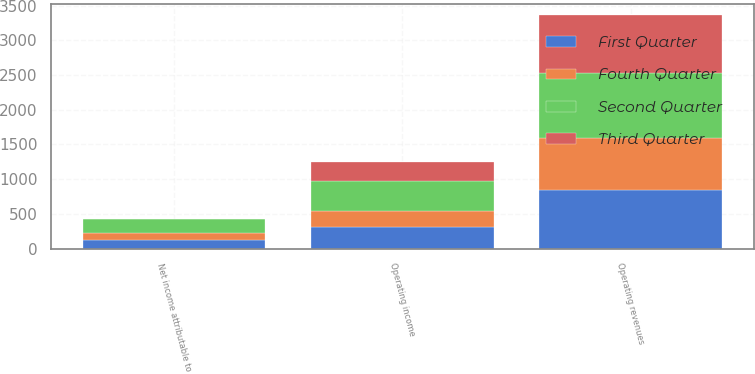Convert chart. <chart><loc_0><loc_0><loc_500><loc_500><stacked_bar_chart><ecel><fcel>Operating revenues<fcel>Operating income<fcel>Net income attributable to<nl><fcel>Fourth Quarter<fcel>756<fcel>230<fcel>93<nl><fcel>First Quarter<fcel>844<fcel>310<fcel>131<nl><fcel>Second Quarter<fcel>936<fcel>432<fcel>203<nl><fcel>Third Quarter<fcel>821<fcel>281<fcel>1<nl></chart> 